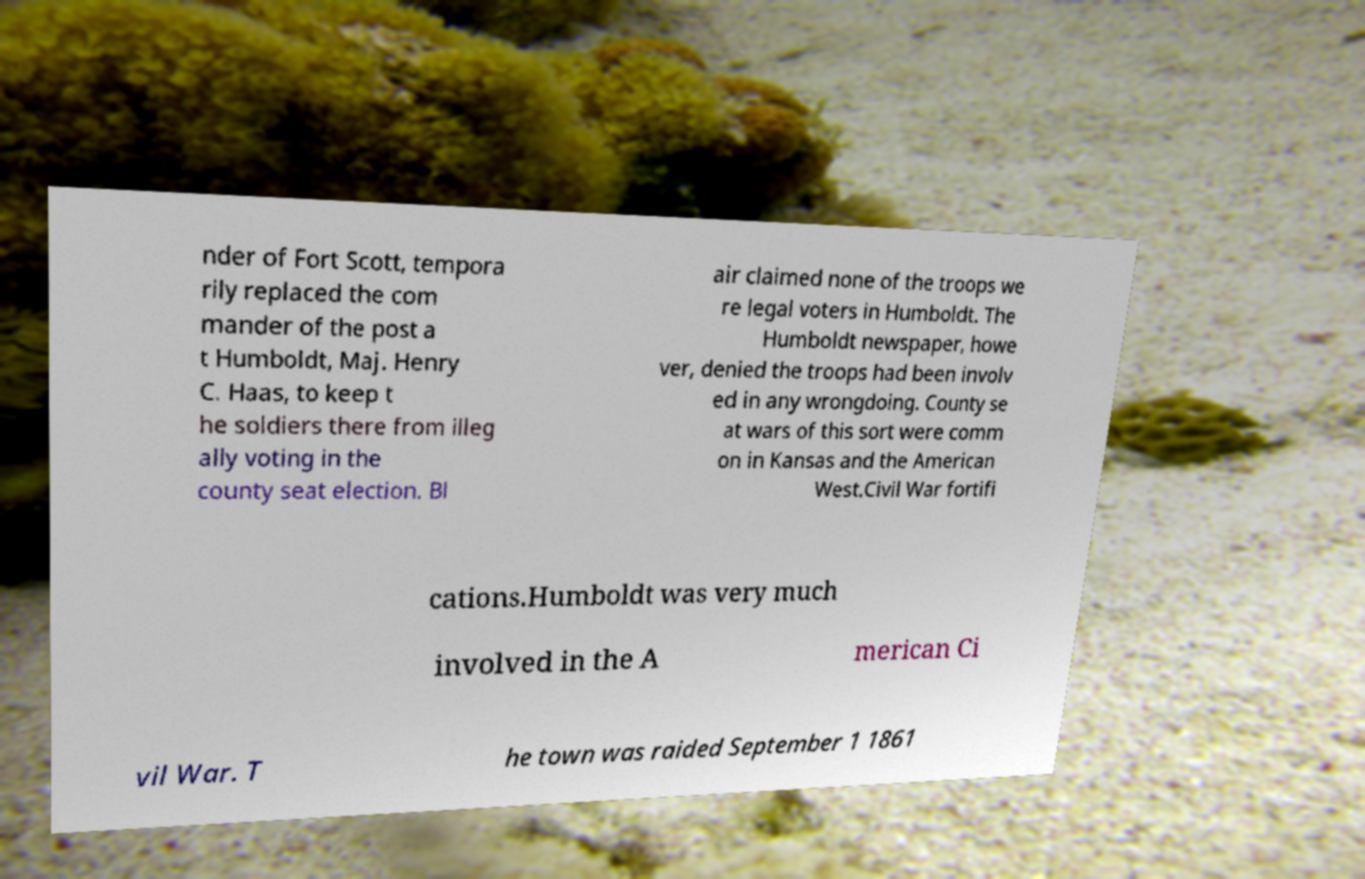For documentation purposes, I need the text within this image transcribed. Could you provide that? nder of Fort Scott, tempora rily replaced the com mander of the post a t Humboldt, Maj. Henry C. Haas, to keep t he soldiers there from illeg ally voting in the county seat election. Bl air claimed none of the troops we re legal voters in Humboldt. The Humboldt newspaper, howe ver, denied the troops had been involv ed in any wrongdoing. County se at wars of this sort were comm on in Kansas and the American West.Civil War fortifi cations.Humboldt was very much involved in the A merican Ci vil War. T he town was raided September 1 1861 